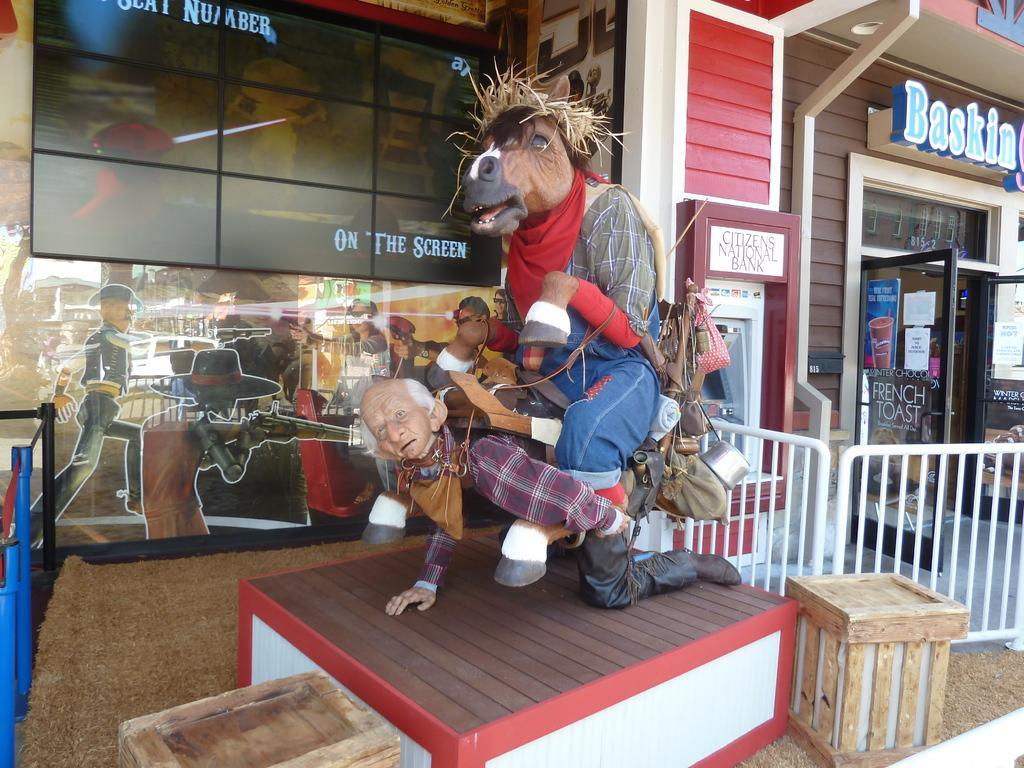In one or two sentences, can you explain what this image depicts? In the middle there is a statue. On the right there is a door ,text and poster. In the background there is a building ,glass and text. 